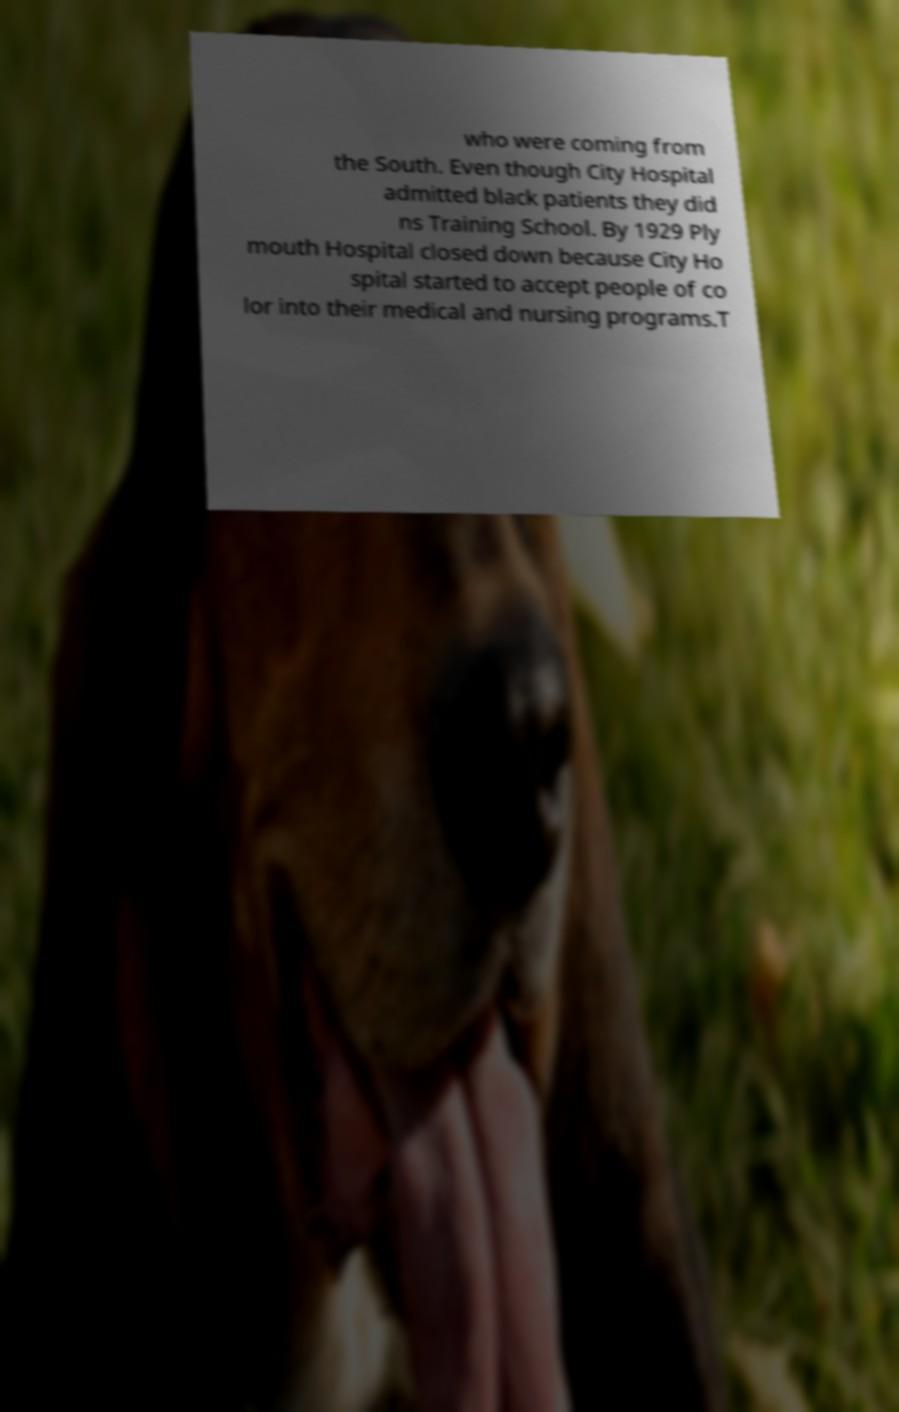What messages or text are displayed in this image? I need them in a readable, typed format. who were coming from the South. Even though City Hospital admitted black patients they did ns Training School. By 1929 Ply mouth Hospital closed down because City Ho spital started to accept people of co lor into their medical and nursing programs.T 